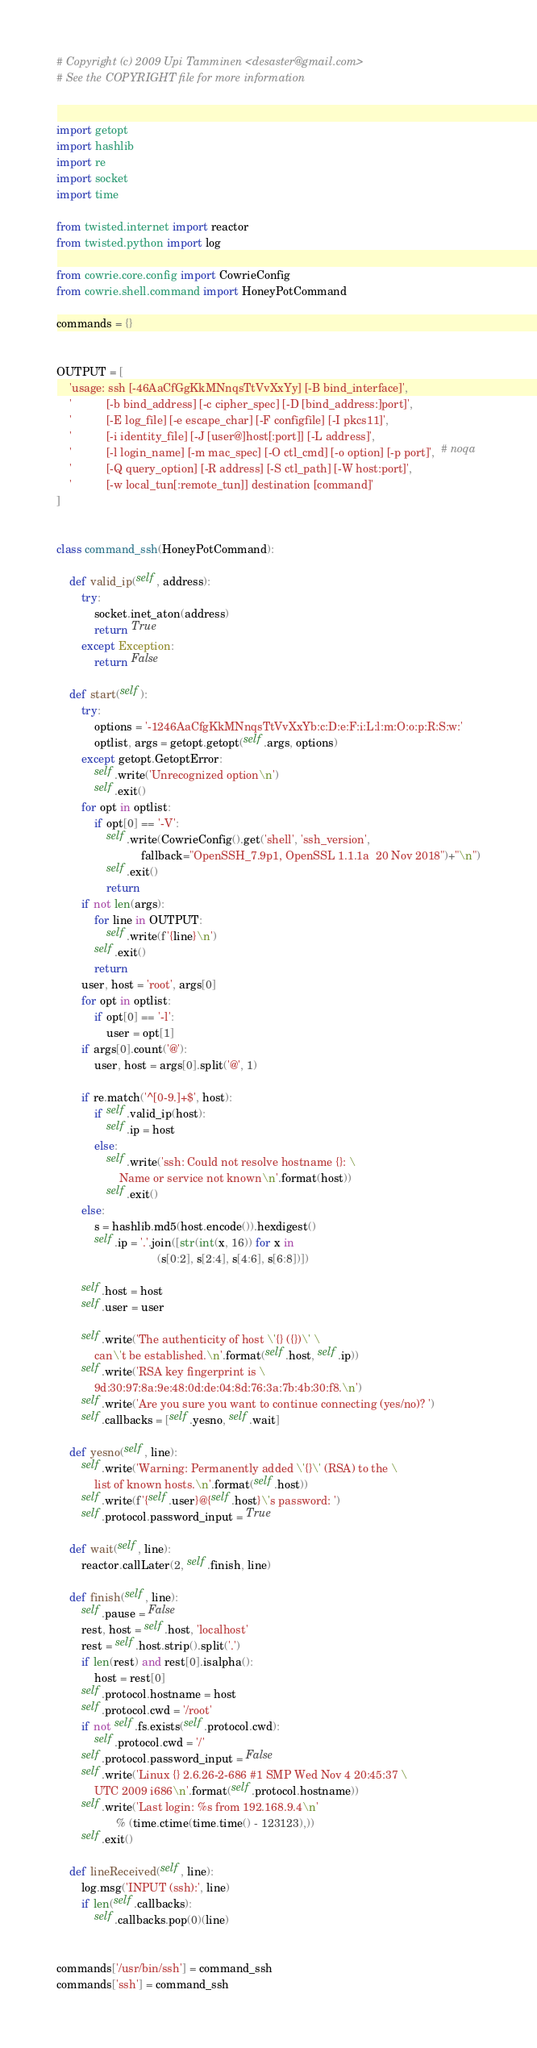Convert code to text. <code><loc_0><loc_0><loc_500><loc_500><_Python_># Copyright (c) 2009 Upi Tamminen <desaster@gmail.com>
# See the COPYRIGHT file for more information


import getopt
import hashlib
import re
import socket
import time

from twisted.internet import reactor
from twisted.python import log

from cowrie.core.config import CowrieConfig
from cowrie.shell.command import HoneyPotCommand

commands = {}


OUTPUT = [
    'usage: ssh [-46AaCfGgKkMNnqsTtVvXxYy] [-B bind_interface]',
    '           [-b bind_address] [-c cipher_spec] [-D [bind_address:]port]',
    '           [-E log_file] [-e escape_char] [-F configfile] [-I pkcs11]',
    '           [-i identity_file] [-J [user@]host[:port]] [-L address]',
    '           [-l login_name] [-m mac_spec] [-O ctl_cmd] [-o option] [-p port]',  # noqa
    '           [-Q query_option] [-R address] [-S ctl_path] [-W host:port]',
    '           [-w local_tun[:remote_tun]] destination [command]'
]


class command_ssh(HoneyPotCommand):

    def valid_ip(self, address):
        try:
            socket.inet_aton(address)
            return True
        except Exception:
            return False

    def start(self):
        try:
            options = '-1246AaCfgKkMNnqsTtVvXxYb:c:D:e:F:i:L:l:m:O:o:p:R:S:w:'
            optlist, args = getopt.getopt(self.args, options)
        except getopt.GetoptError:
            self.write('Unrecognized option\n')
            self.exit()
        for opt in optlist:
            if opt[0] == '-V':
                self.write(CowrieConfig().get('shell', 'ssh_version',
                           fallback="OpenSSH_7.9p1, OpenSSL 1.1.1a  20 Nov 2018")+"\n")
                self.exit()
                return
        if not len(args):
            for line in OUTPUT:
                self.write(f'{line}\n')
            self.exit()
            return
        user, host = 'root', args[0]
        for opt in optlist:
            if opt[0] == '-l':
                user = opt[1]
        if args[0].count('@'):
            user, host = args[0].split('@', 1)

        if re.match('^[0-9.]+$', host):
            if self.valid_ip(host):
                self.ip = host
            else:
                self.write('ssh: Could not resolve hostname {}: \
                    Name or service not known\n'.format(host))
                self.exit()
        else:
            s = hashlib.md5(host.encode()).hexdigest()
            self.ip = '.'.join([str(int(x, 16)) for x in
                                (s[0:2], s[2:4], s[4:6], s[6:8])])

        self.host = host
        self.user = user

        self.write('The authenticity of host \'{} ({})\' \
            can\'t be established.\n'.format(self.host, self.ip))
        self.write('RSA key fingerprint is \
            9d:30:97:8a:9e:48:0d:de:04:8d:76:3a:7b:4b:30:f8.\n')
        self.write('Are you sure you want to continue connecting (yes/no)? ')
        self.callbacks = [self.yesno, self.wait]

    def yesno(self, line):
        self.write('Warning: Permanently added \'{}\' (RSA) to the \
            list of known hosts.\n'.format(self.host))
        self.write(f'{self.user}@{self.host}\'s password: ')
        self.protocol.password_input = True

    def wait(self, line):
        reactor.callLater(2, self.finish, line)

    def finish(self, line):
        self.pause = False
        rest, host = self.host, 'localhost'
        rest = self.host.strip().split('.')
        if len(rest) and rest[0].isalpha():
            host = rest[0]
        self.protocol.hostname = host
        self.protocol.cwd = '/root'
        if not self.fs.exists(self.protocol.cwd):
            self.protocol.cwd = '/'
        self.protocol.password_input = False
        self.write('Linux {} 2.6.26-2-686 #1 SMP Wed Nov 4 20:45:37 \
            UTC 2009 i686\n'.format(self.protocol.hostname))
        self.write('Last login: %s from 192.168.9.4\n'
                   % (time.ctime(time.time() - 123123),))
        self.exit()

    def lineReceived(self, line):
        log.msg('INPUT (ssh):', line)
        if len(self.callbacks):
            self.callbacks.pop(0)(line)


commands['/usr/bin/ssh'] = command_ssh
commands['ssh'] = command_ssh
</code> 